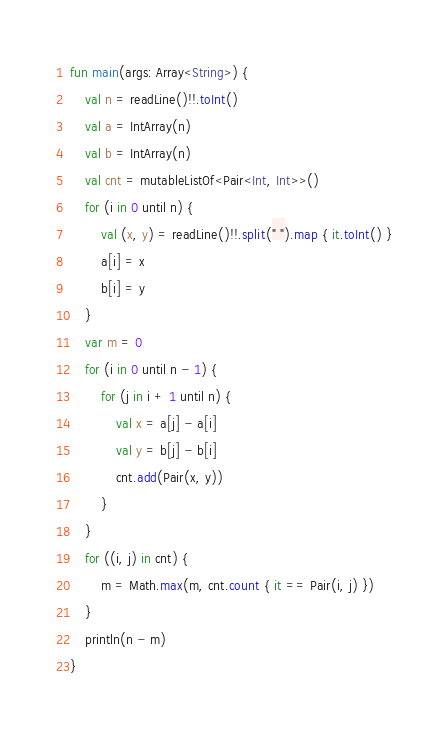Convert code to text. <code><loc_0><loc_0><loc_500><loc_500><_Kotlin_>fun main(args: Array<String>) {
    val n = readLine()!!.toInt()
    val a = IntArray(n)
    val b = IntArray(n)
    val cnt = mutableListOf<Pair<Int, Int>>()
    for (i in 0 until n) {
        val (x, y) = readLine()!!.split(" ").map { it.toInt() }
        a[i] = x
        b[i] = y
    }
    var m = 0
    for (i in 0 until n - 1) {
        for (j in i + 1 until n) {
            val x = a[j] - a[i]
            val y = b[j] - b[i]
            cnt.add(Pair(x, y))
        }
    }
    for ((i, j) in cnt) {
        m = Math.max(m, cnt.count { it == Pair(i, j) })
    }
    println(n - m)
}</code> 